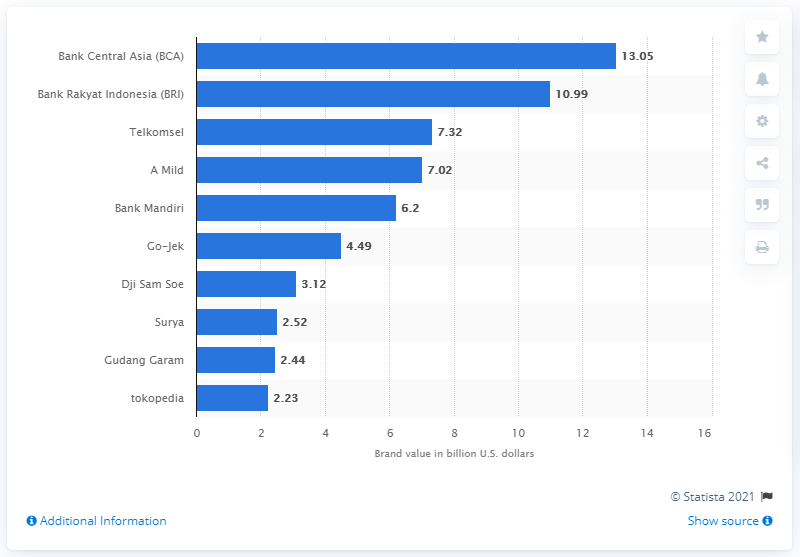Can you tell me about the third-ranked company in terms of brand value? The third-ranked company by brand value on the chart is Telkomsel, with a brand value of approximately 7.32 billion U.S. dollars. 